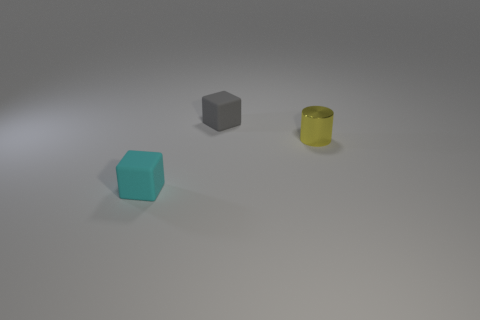Are there any other things that are the same material as the yellow thing?
Keep it short and to the point. No. There is a matte block behind the tiny yellow metal object; is its color the same as the small matte thing that is in front of the metallic cylinder?
Ensure brevity in your answer.  No. Are there more shiny cylinders in front of the tiny metallic cylinder than small gray metallic things?
Your answer should be very brief. No. What number of other objects are the same color as the tiny metal object?
Your answer should be very brief. 0. Does the matte cube behind the yellow thing have the same size as the cyan object?
Provide a succinct answer. Yes. Is there a cyan shiny cylinder of the same size as the gray matte object?
Your response must be concise. No. The matte object behind the small yellow object is what color?
Keep it short and to the point. Gray. The small object that is in front of the gray rubber cube and on the right side of the tiny cyan rubber cube has what shape?
Offer a terse response. Cylinder. What number of other things have the same shape as the metallic object?
Provide a succinct answer. 0. How many small yellow balls are there?
Offer a very short reply. 0. 